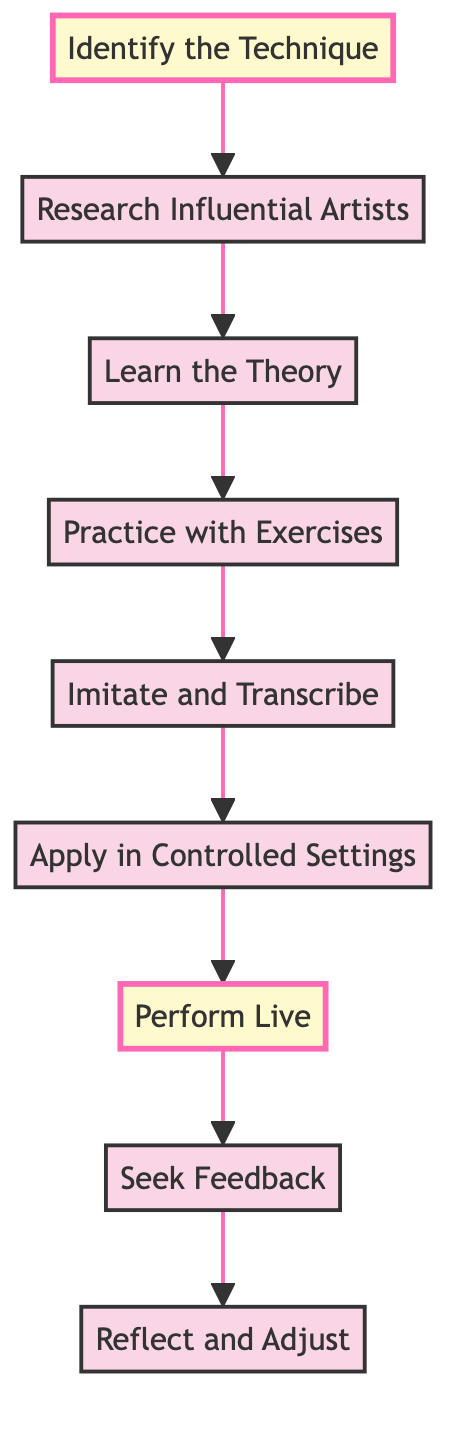What is the first step in mastering a new improvisational technique? The first step, indicated in the diagram, is "Identify the Technique." This is the starting point of the flow chart.
Answer: Identify the Technique How many steps are there in total? By counting the nodes in the flow chart, there are nine distinct steps shown in the progression toward mastering a new improvisational technique.
Answer: 9 Which step comes immediately after "Learn the Theory"? Looking at the flow chart order, the step that follows "Learn the Theory" is "Practice with Exercises." This shows the progression from understanding to applying the theoretical knowledge.
Answer: Practice with Exercises What relationship exists between "Perform Live" and "Seek Feedback"? "Perform Live" is followed directly by "Seek Feedback" in the flow chart, indicating that after applying the technique in a live setting, it is important to gather feedback for improvement.
Answer: Perform Live → Seek Feedback What is the last step in the process? The final step in the diagram is "Reflect and Adjust," marking the endpoint of the flow related to mastering the new improvisational technique.
Answer: Reflect and Adjust Which step focuses on imitating and transcribing solos? The flow chart indicates that the step "Imitate and Transcribe" specifically emphasizes this activity, placed sequentially after practicing exercises and before applying techniques in controlled settings.
Answer: Imitate and Transcribe How does the flow from "Research Influential Artists" to "Learn the Theory" progress? The diagram shows a direct flow from "Research Influential Artists" leading to "Learn the Theory," suggesting that after researching, one should delve into the theoretical aspects of the identified technique.
Answer: Research Influential Artists → Learn the Theory What type of environments are suggested for applying the technique? The flow chart states to "Apply in Controlled Settings," which indicates that low-pressure environments like practice sessions or rehearsals are ideal for integrating the technique before performing live.
Answer: Controlled Settings What does the highlighted step in the diagram signify? The highlighted steps, "Identify the Technique" and "Perform Live," suggest critical milestones in the process—starting off by choosing a technique and culminating with its live implementation.
Answer: Critical milestones 